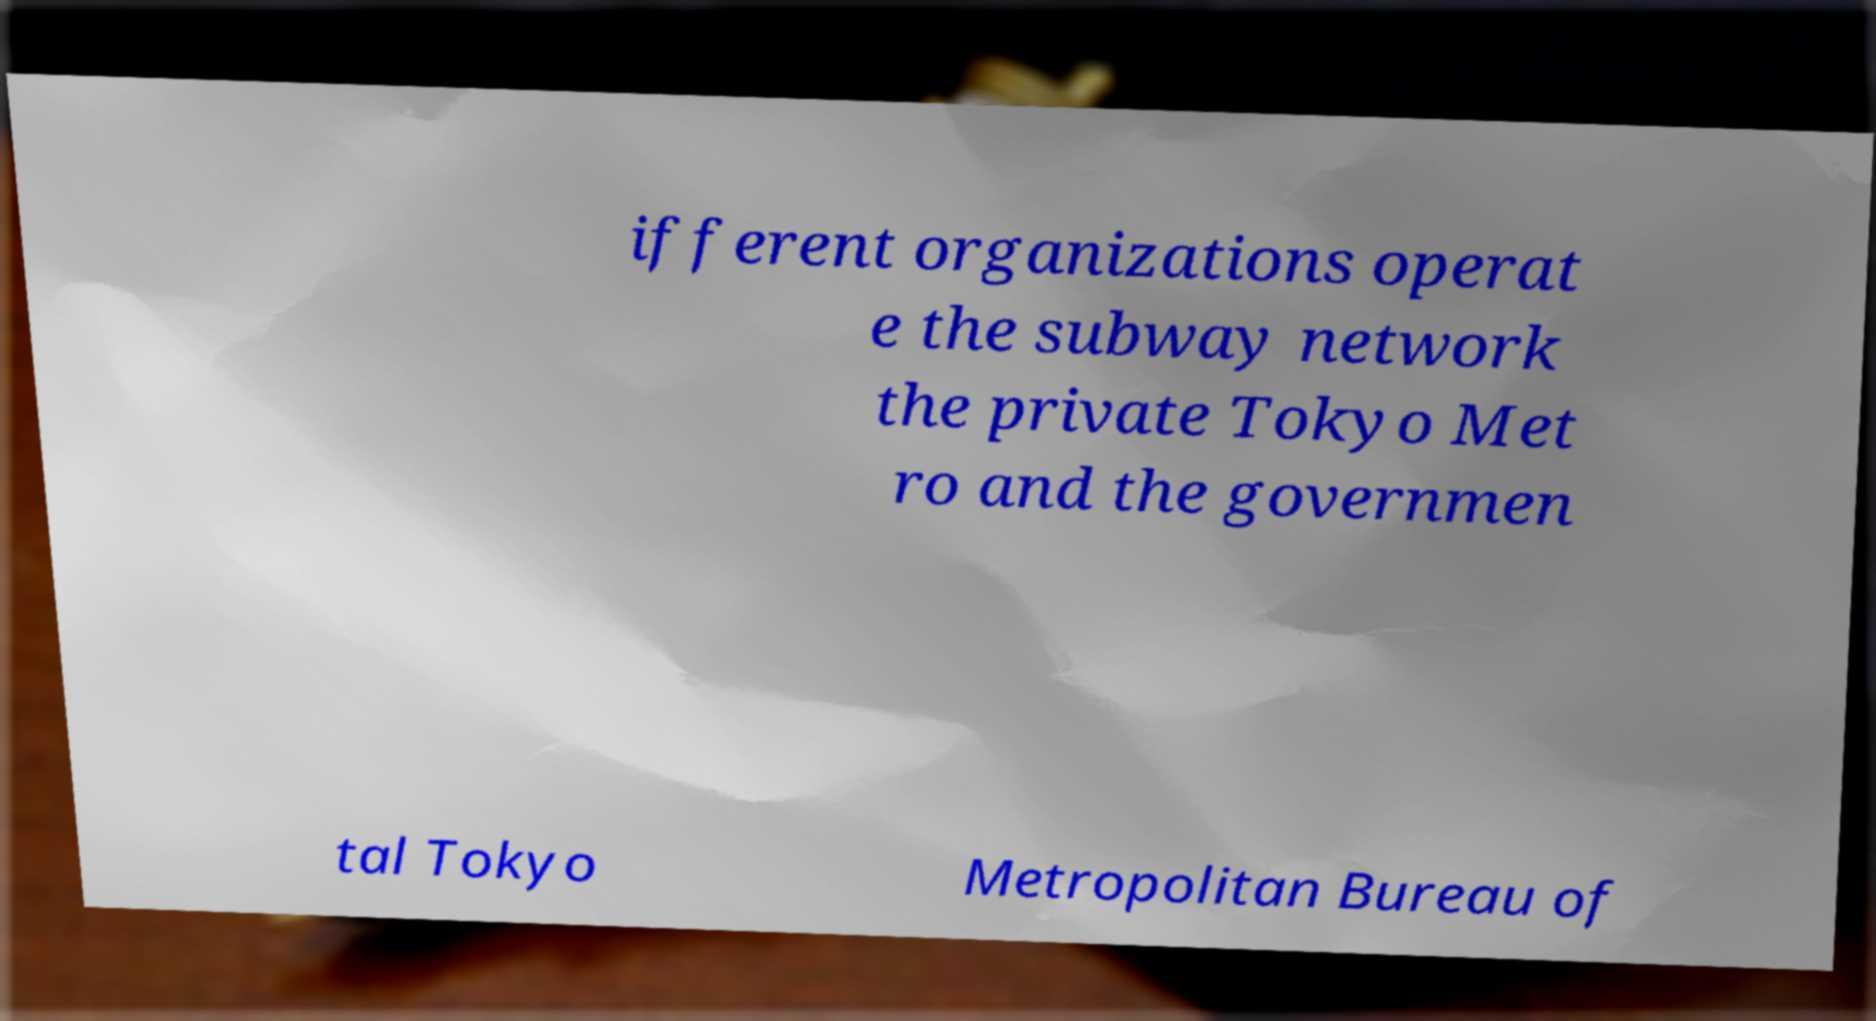Can you accurately transcribe the text from the provided image for me? ifferent organizations operat e the subway network the private Tokyo Met ro and the governmen tal Tokyo Metropolitan Bureau of 